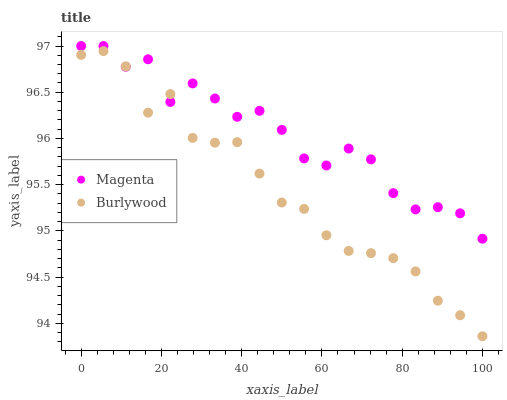Does Burlywood have the minimum area under the curve?
Answer yes or no. Yes. Does Magenta have the maximum area under the curve?
Answer yes or no. Yes. Does Magenta have the minimum area under the curve?
Answer yes or no. No. Is Burlywood the smoothest?
Answer yes or no. Yes. Is Magenta the roughest?
Answer yes or no. Yes. Is Magenta the smoothest?
Answer yes or no. No. Does Burlywood have the lowest value?
Answer yes or no. Yes. Does Magenta have the lowest value?
Answer yes or no. No. Does Magenta have the highest value?
Answer yes or no. Yes. Does Burlywood intersect Magenta?
Answer yes or no. Yes. Is Burlywood less than Magenta?
Answer yes or no. No. Is Burlywood greater than Magenta?
Answer yes or no. No. 